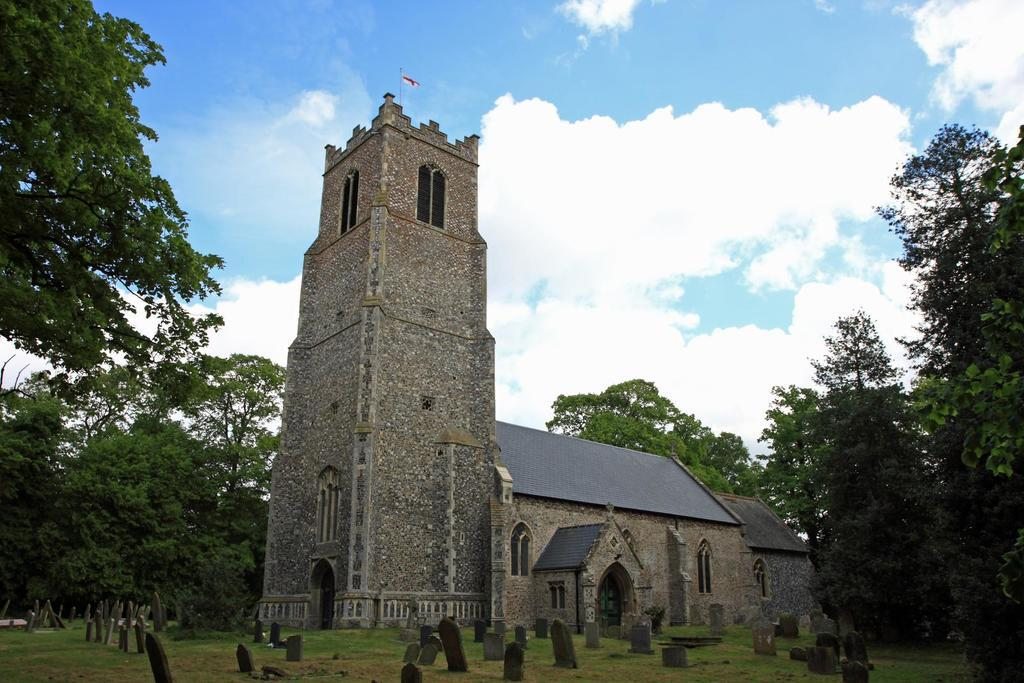What type of location is depicted in the image? There is a graveyard in the image. What structure can be seen within the graveyard? There is a big house in the image. How is the house positioned in relation to the graves? The house is located between the graves in the graveyard. What can be observed about the surrounding environment of the house? There are plenty of trees around the house. What is the tendency of the yarn to unravel in the image? There is no yarn present in the image, so it is not possible to determine its tendency to unravel. 